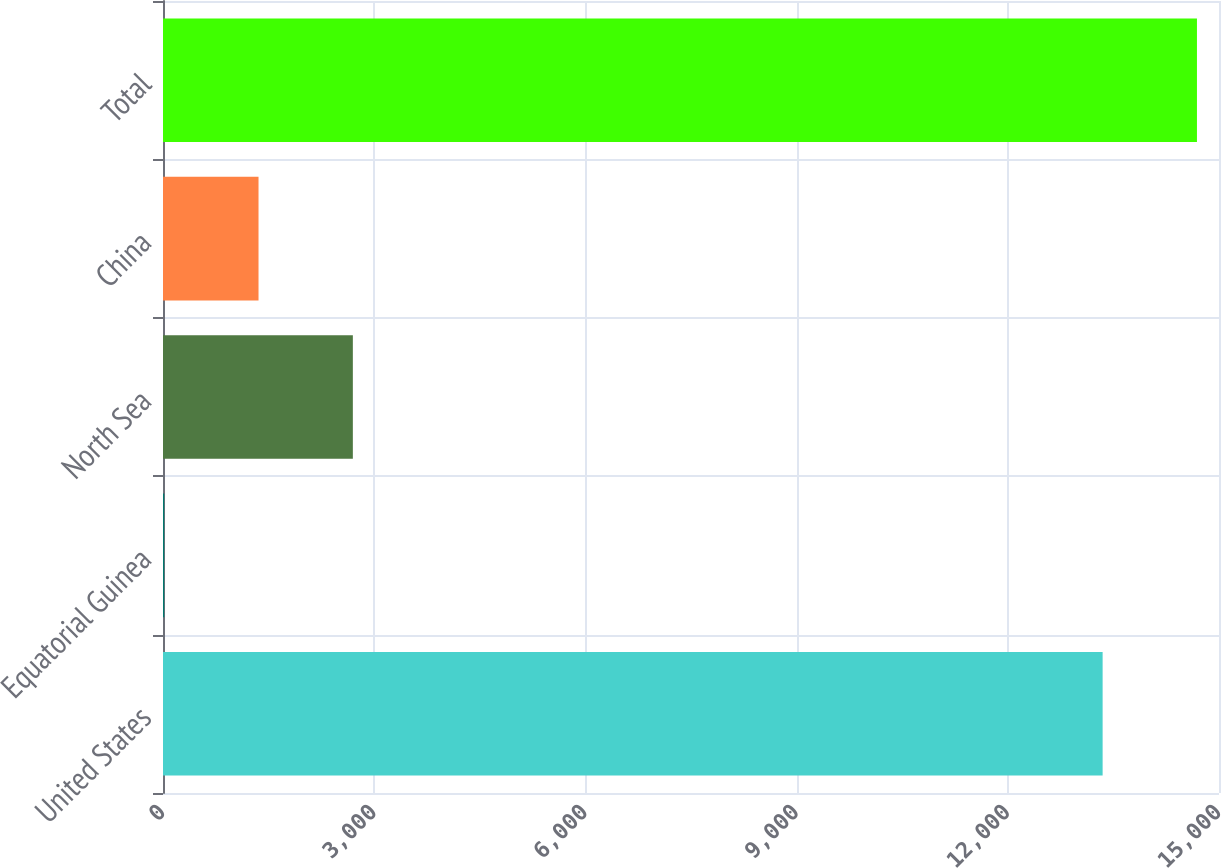<chart> <loc_0><loc_0><loc_500><loc_500><bar_chart><fcel>United States<fcel>Equatorial Guinea<fcel>North Sea<fcel>China<fcel>Total<nl><fcel>13347<fcel>17<fcel>2696.8<fcel>1356.9<fcel>14686.9<nl></chart> 